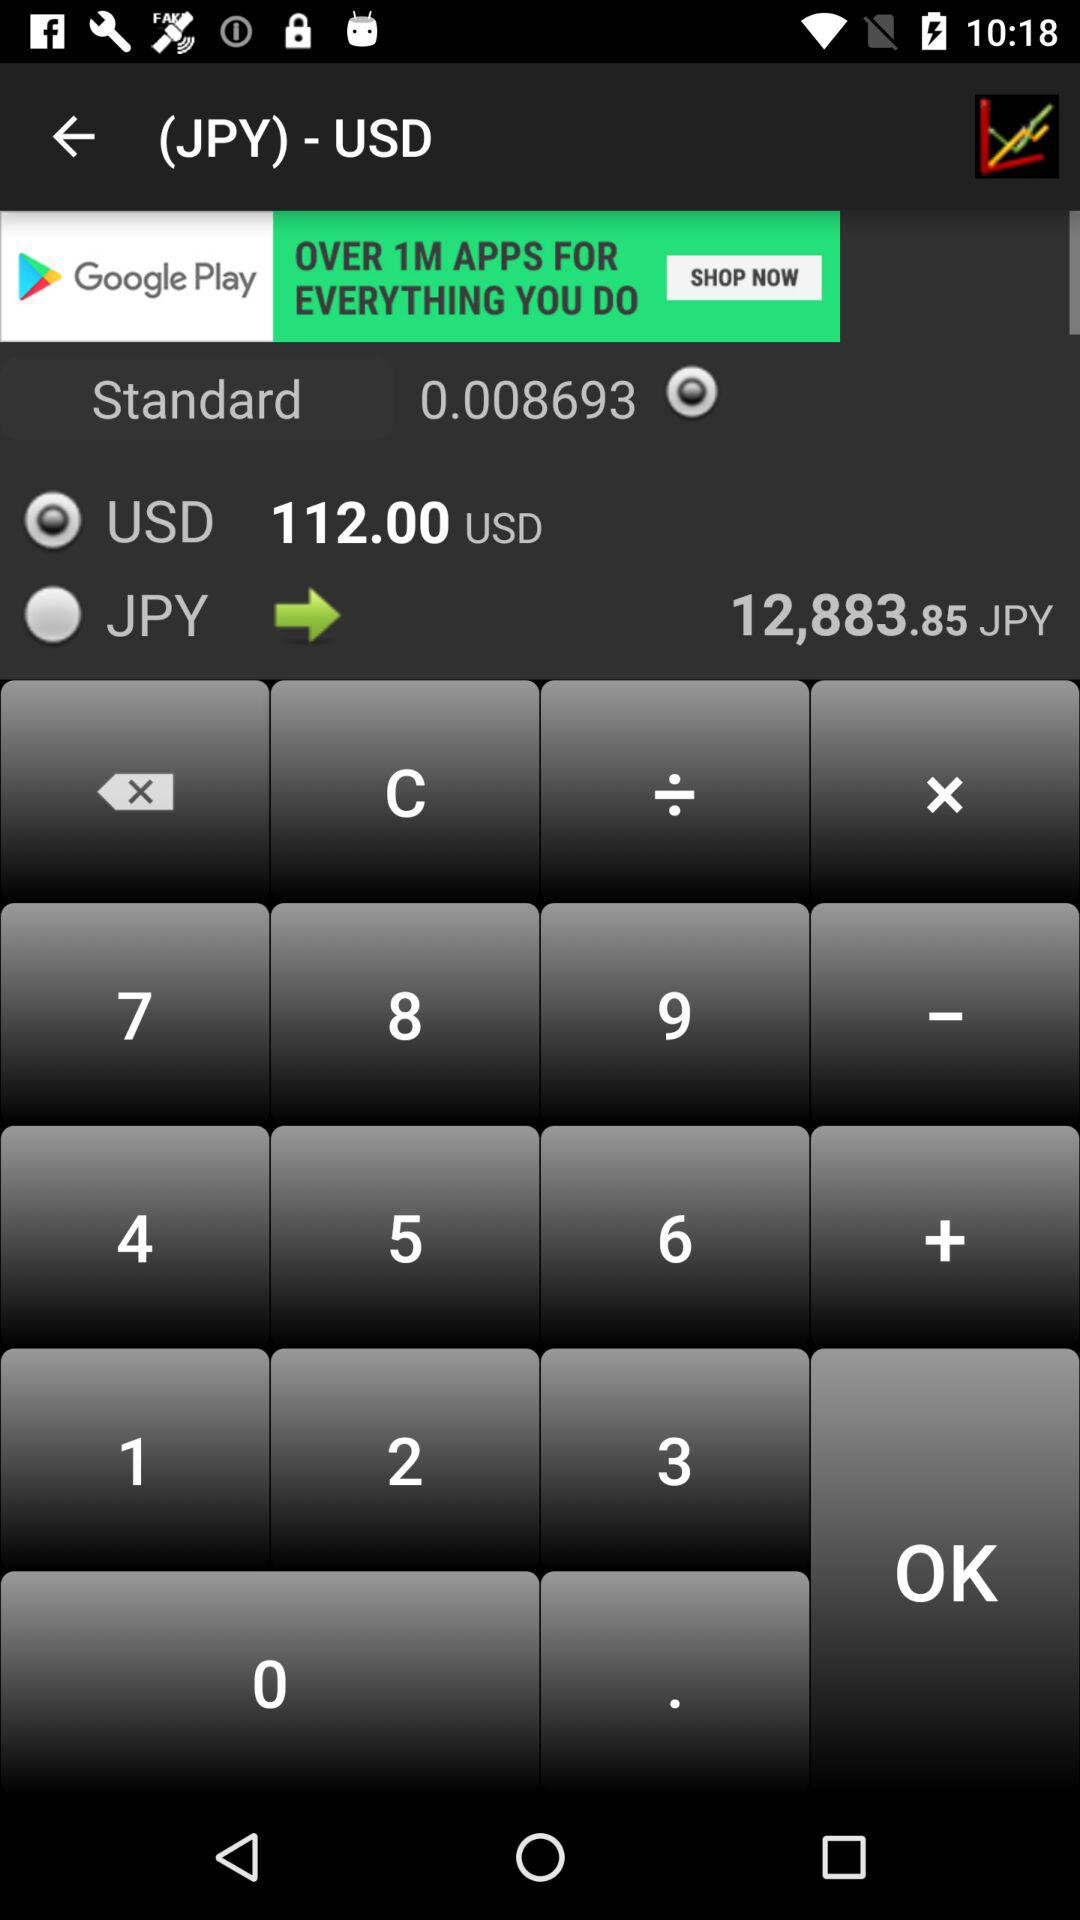What is the value of standard? The value of the standard is 0.008693. 